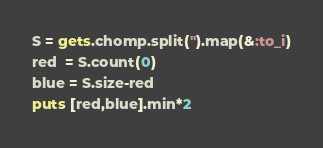Convert code to text. <code><loc_0><loc_0><loc_500><loc_500><_Ruby_>S = gets.chomp.split('').map(&:to_i)
red  = S.count(0)
blue = S.size-red
puts [red,blue].min*2
</code> 